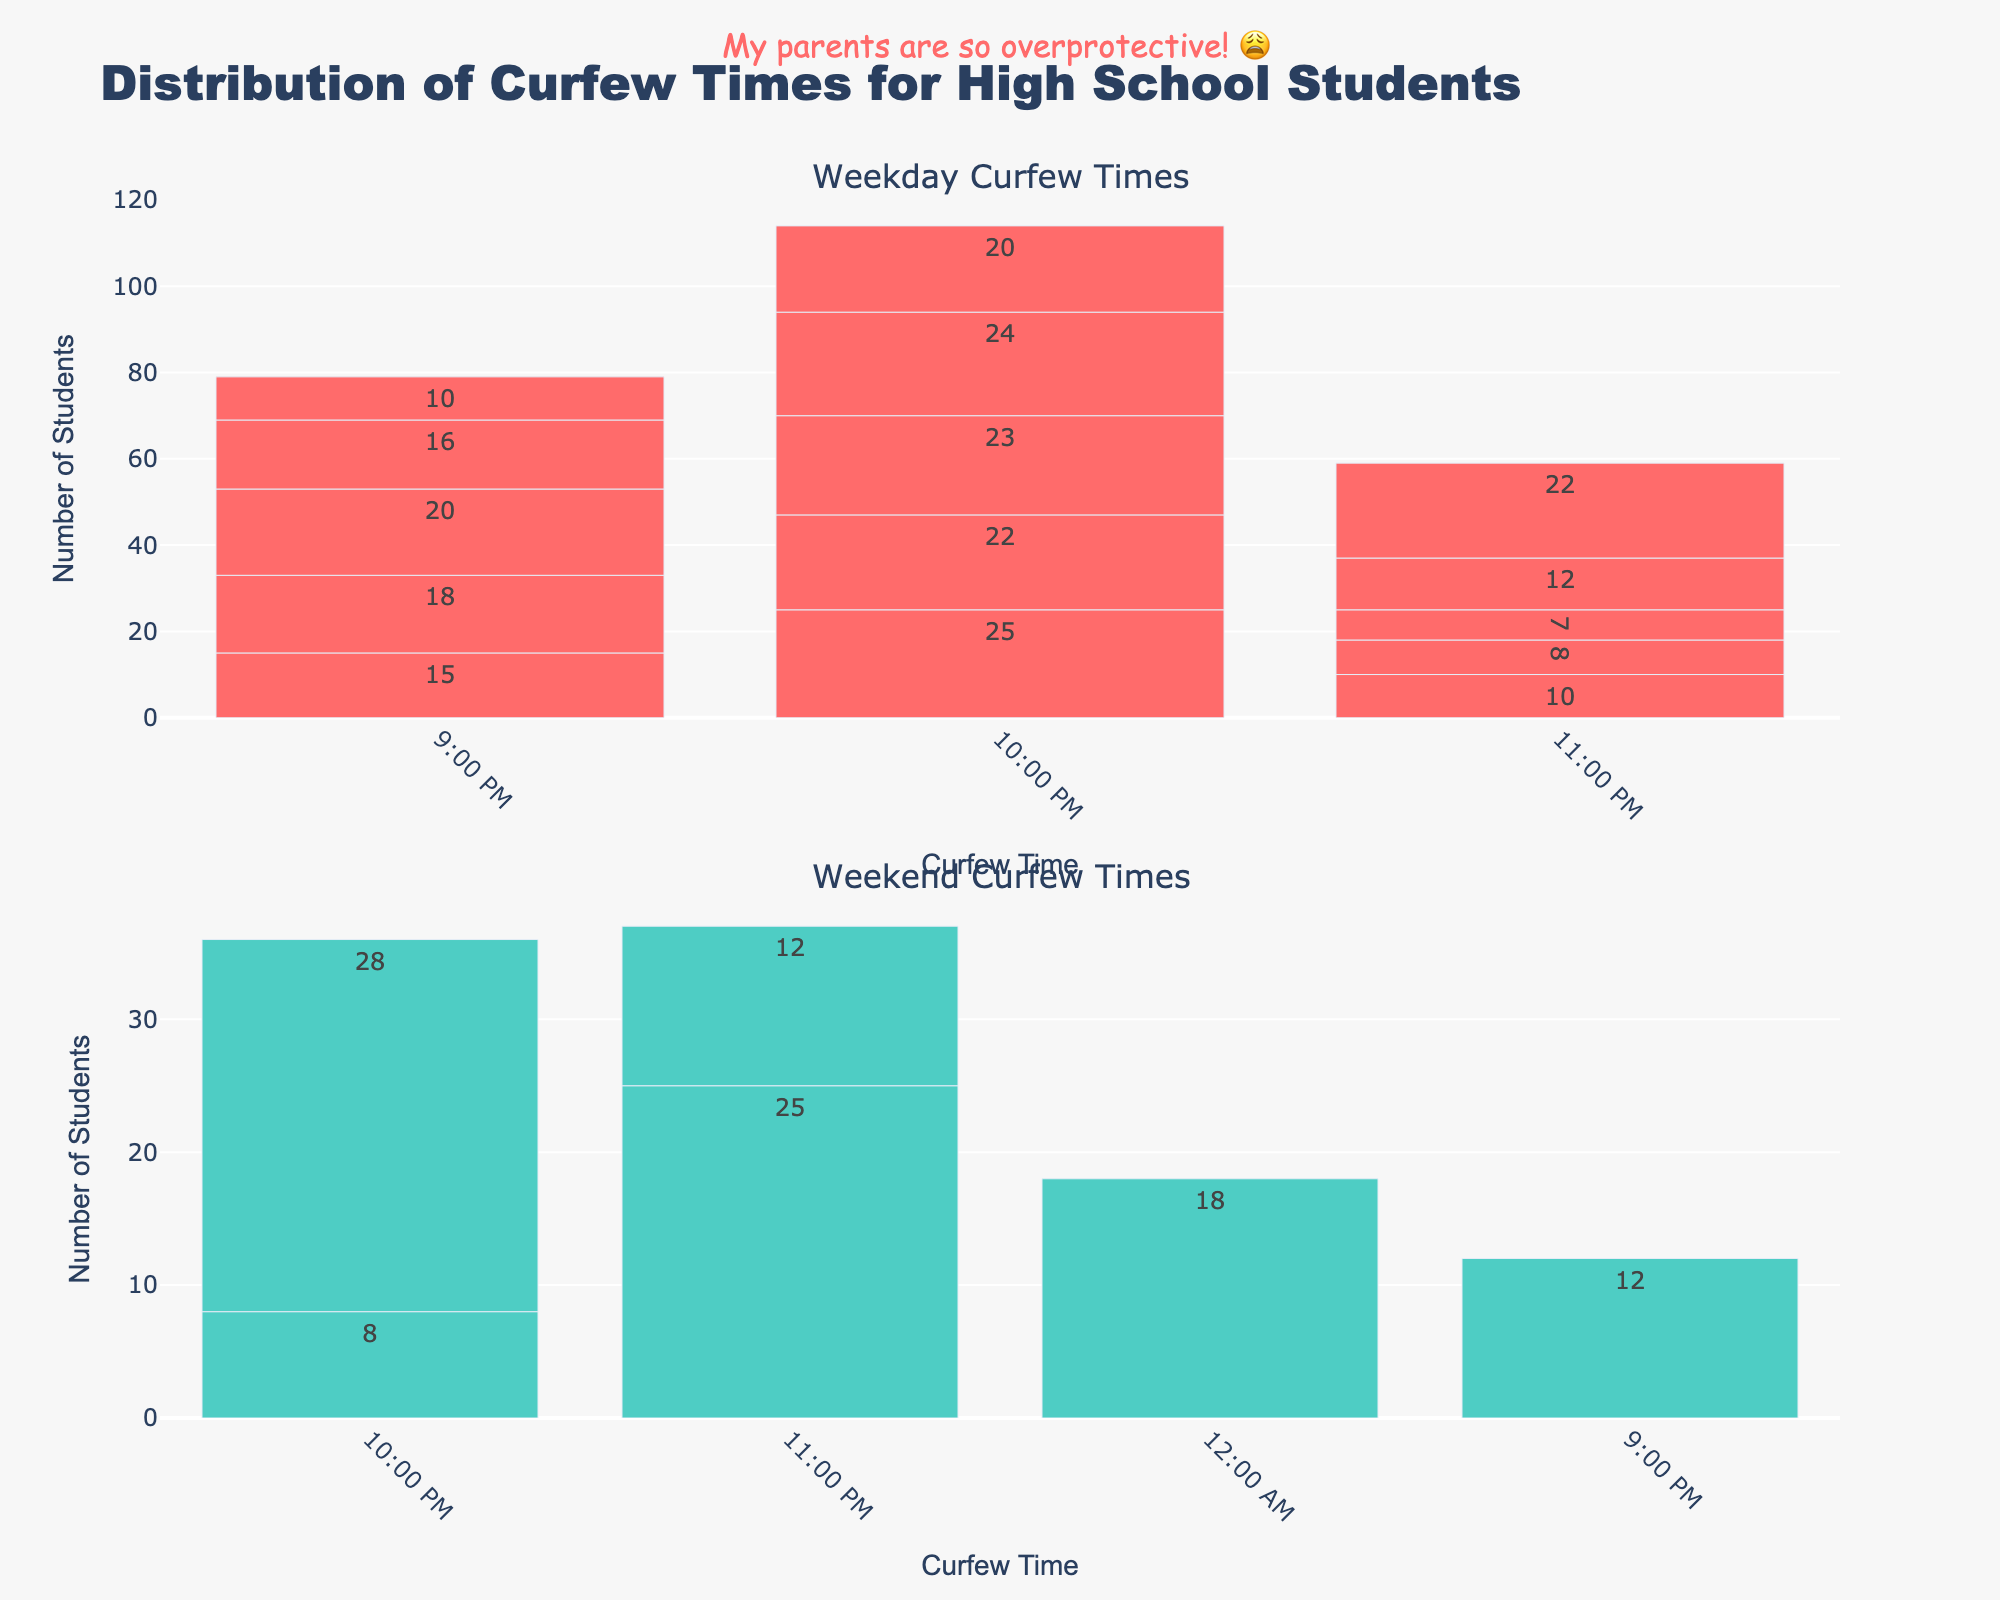What's the title of the figure? The title is usually displayed prominently at the top of the figure. In this case, it is written in large, bold text.
Answer: Distribution of Curfew Times for High School Students What's the color used for the Weekend histogram bars? The colors of the bars on the histogram can be directly observed. In this case, the Weekend histogram bars are shown in a visually distinct color.
Answer: Teal Which curfew time on weekdays has the highest count of students? By looking at the tallest bar in the Weekday subplot, we can identify the curfew time that corresponds to the highest count.
Answer: 10:00 PM How many students have a curfew at 9:00 PM on Friday? Locate the bar corresponding to '9:00 PM' in the Weekday subplot and read the value associated with Friday.
Answer: 10 Which day has the latest curfew time and what is it? Find the latest curfew time on the x-axis and then identify the corresponding day by looking at the appropriate bar.
Answer: Saturday at 12:00 AM What is the average number of students with curfew times on Sunday? Add the counts of students for each curfew time on Sunday and then divide by the number of curfew times listed (three times). (12 + 28 + 12)/3 = 52/3 = 17.33
Answer: 17.33 How does the count of students with a 10:00 PM curfew on weekdays compare to weekends? Compare the height of the 10:00 PM bars in both weekday and weekend subplots.
Answer: More students on weekends (28 vs. 114) Which curfew time on weekends has the lowest count of students? Identify the shortest bar in the Weekend subplot and note the curfew time it represents.
Answer: 10:00 PM on Saturday What is the total number of students with a curfew at 11:00 PM on weekdays? Sum the counts for '11:00 PM' across all weekdays, i.e., Monday to Friday. (10 + 8 + 7 + 12 + 22) = 59
Answer: 59 Is there a curfew time on weekdays that no students have? Check the Weekday subplot to see if there is any curfew time bar missing or having a count of zero.
Answer: No 